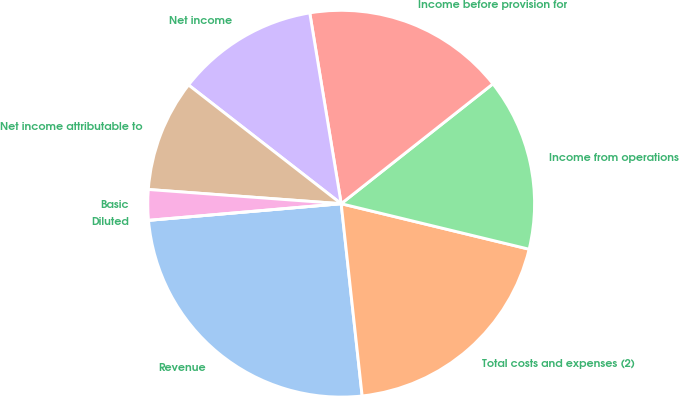Convert chart to OTSL. <chart><loc_0><loc_0><loc_500><loc_500><pie_chart><fcel>Revenue<fcel>Total costs and expenses (2)<fcel>Income from operations<fcel>Income before provision for<fcel>Net income<fcel>Net income attributable to<fcel>Basic<fcel>Diluted<nl><fcel>25.36%<fcel>19.49%<fcel>14.42%<fcel>16.96%<fcel>11.88%<fcel>9.35%<fcel>2.54%<fcel>0.0%<nl></chart> 